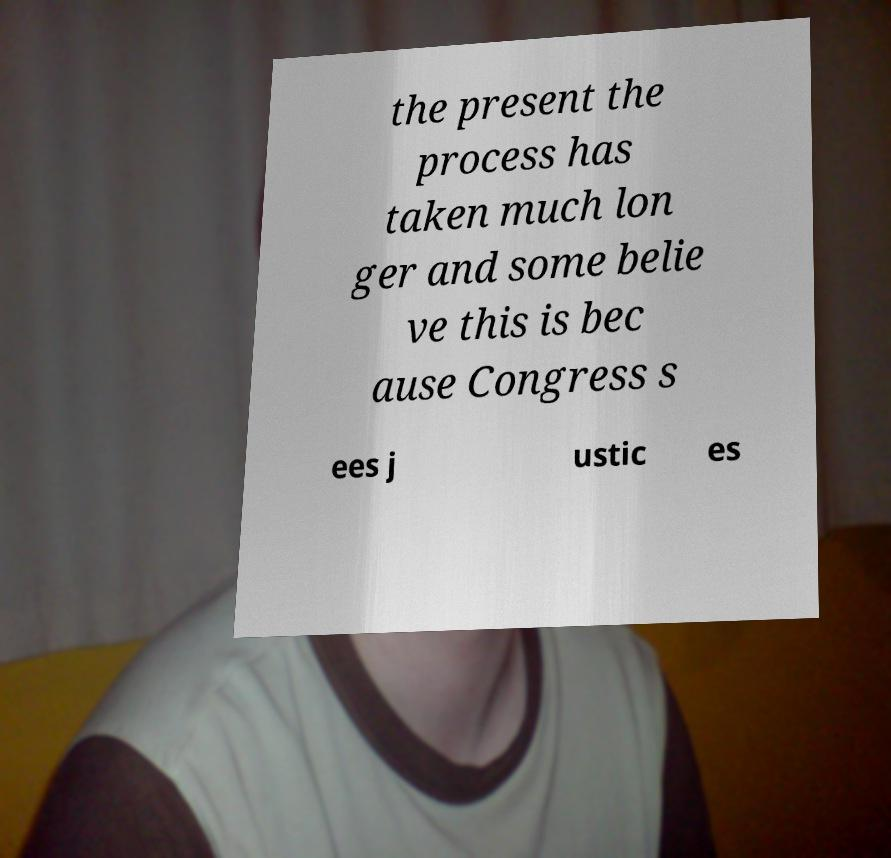What messages or text are displayed in this image? I need them in a readable, typed format. the present the process has taken much lon ger and some belie ve this is bec ause Congress s ees j ustic es 